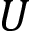Convert formula to latex. <formula><loc_0><loc_0><loc_500><loc_500>U</formula> 